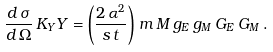<formula> <loc_0><loc_0><loc_500><loc_500>\frac { d \, \sigma } { d \, \Omega } \, K _ { Y } Y = \left ( \frac { 2 \, \alpha ^ { 2 } } { s \, t } \right ) \, m \, M \, g _ { E } \, g _ { M } \, G _ { E } \, G _ { M } \, .</formula> 